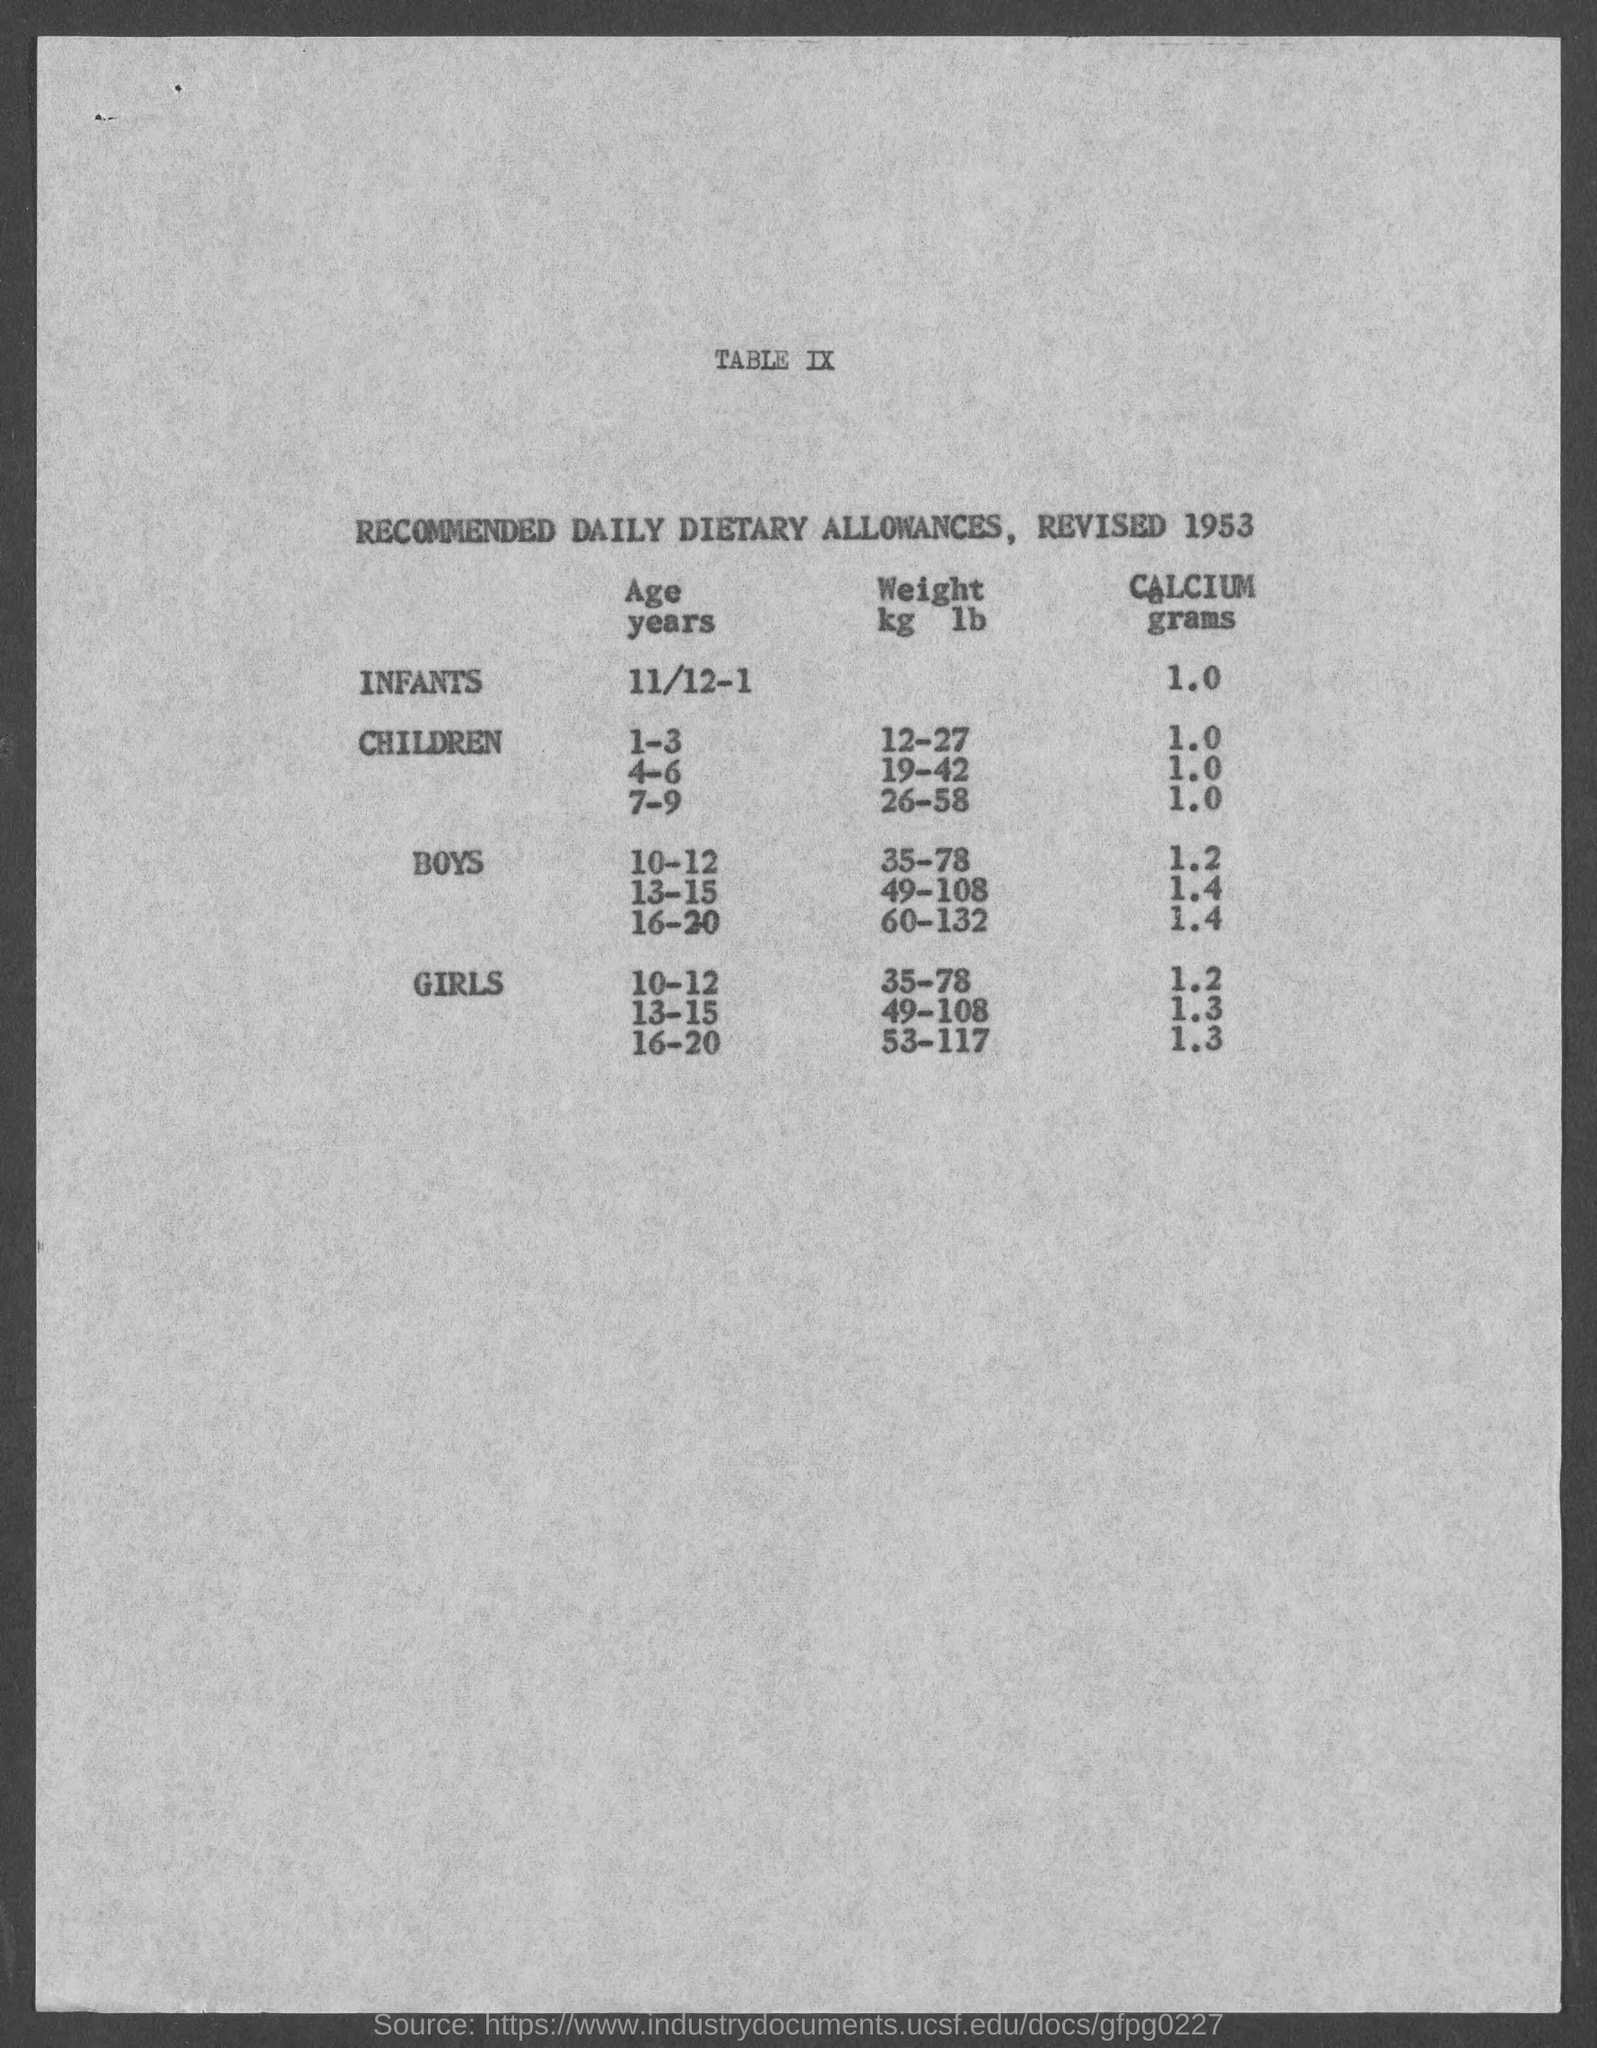What does the recommended calcium intake in grams for boys aged 10-12 according to this historical document? In this historical document, the recommended calcium intake for boys aged 10-12 is specified as 1.2 grams. 